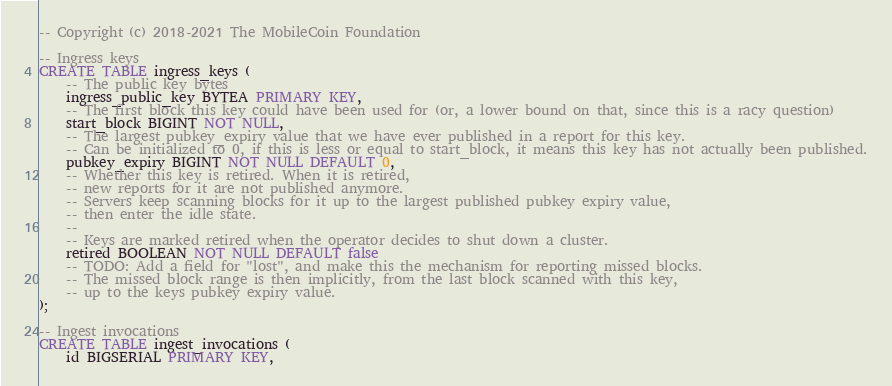<code> <loc_0><loc_0><loc_500><loc_500><_SQL_>-- Copyright (c) 2018-2021 The MobileCoin Foundation

-- Ingress keys
CREATE TABLE ingress_keys (
    -- The public key bytes
    ingress_public_key BYTEA PRIMARY KEY,
    -- The first block this key could have been used for (or, a lower bound on that, since this is a racy question)
    start_block BIGINT NOT NULL,
    -- The largest pubkey_expiry value that we have ever published in a report for this key.
    -- Can be initialized to 0, if this is less or equal to start_block, it means this key has not actually been published.
    pubkey_expiry BIGINT NOT NULL DEFAULT 0,
    -- Whether this key is retired. When it is retired,
    -- new reports for it are not published anymore.
    -- Servers keep scanning blocks for it up to the largest published pubkey expiry value,
    -- then enter the idle state.
    --
    -- Keys are marked retired when the operator decides to shut down a cluster.
    retired BOOLEAN NOT NULL DEFAULT false
    -- TODO: Add a field for "lost", and make this the mechanism for reporting missed blocks.
    -- The missed block range is then implicitly, from the last block scanned with this key,
    -- up to the keys pubkey expiry value.
);

-- Ingest invocations
CREATE TABLE ingest_invocations (
    id BIGSERIAL PRIMARY KEY,</code> 